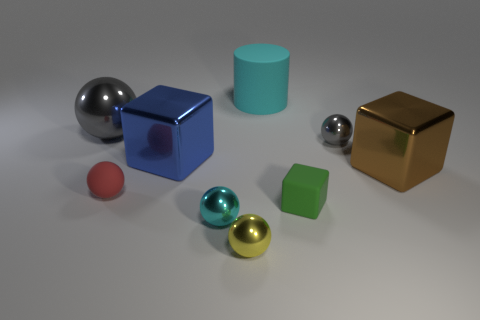Is the shape of the blue shiny thing the same as the large gray thing?
Ensure brevity in your answer.  No. There is a tiny green thing that is the same material as the large cyan cylinder; what is its shape?
Offer a very short reply. Cube. What number of large objects are green objects or blue things?
Ensure brevity in your answer.  1. Is there a ball in front of the large metal object in front of the big blue block?
Offer a terse response. Yes. Are any small gray rubber spheres visible?
Provide a short and direct response. No. The small thing behind the large metallic thing right of the yellow shiny sphere is what color?
Provide a succinct answer. Gray. What material is the cyan thing that is the same shape as the large gray metallic thing?
Offer a very short reply. Metal. How many red rubber spheres are the same size as the green cube?
Provide a short and direct response. 1. What size is the cyan ball that is made of the same material as the yellow sphere?
Provide a short and direct response. Small. What number of large cyan things are the same shape as the small green object?
Your response must be concise. 0. 